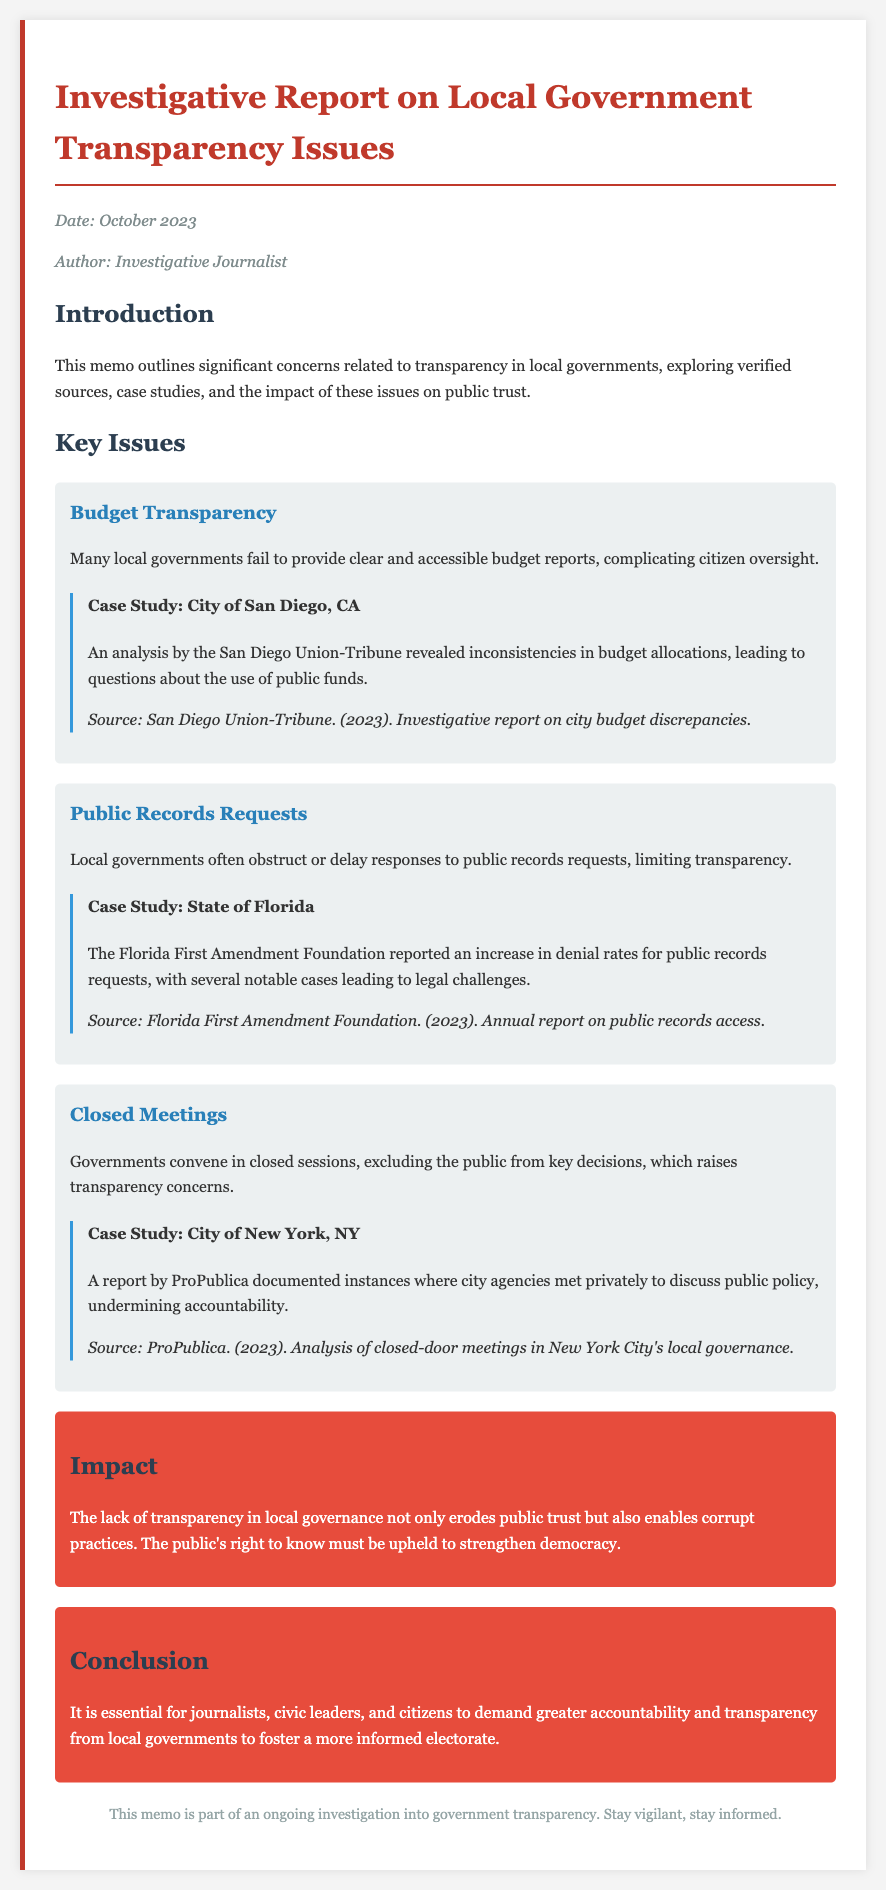what is the date of the memo? The date of the memo is stated in the meta section as October 2023.
Answer: October 2023 who is the author of the memo? The author of the memo is listed in the meta section as Investigative Journalist.
Answer: Investigative Journalist what issue is highlighted regarding budget transparency? The issue highlighted is that many local governments fail to provide clear and accessible budget reports.
Answer: Clear and accessible budget reports how many case studies are presented in the document? There are three case studies presented, one for each key issue outlined.
Answer: Three which city is mentioned in the budget transparency case study? The city mentioned in the budget transparency case study is San Diego, CA.
Answer: San Diego, CA what was reported by the Florida First Amendment Foundation regarding public records requests? They reported an increase in denial rates for public records requests.
Answer: Increase in denial rates what is the impact of the lack of transparency in local governance? The lack of transparency erodes public trust and enables corrupt practices.
Answer: Erodes public trust and enables corrupt practices what does the conclusion urge journalists and citizens to do? The conclusion urges them to demand greater accountability and transparency from local governments.
Answer: Demand greater accountability and transparency 